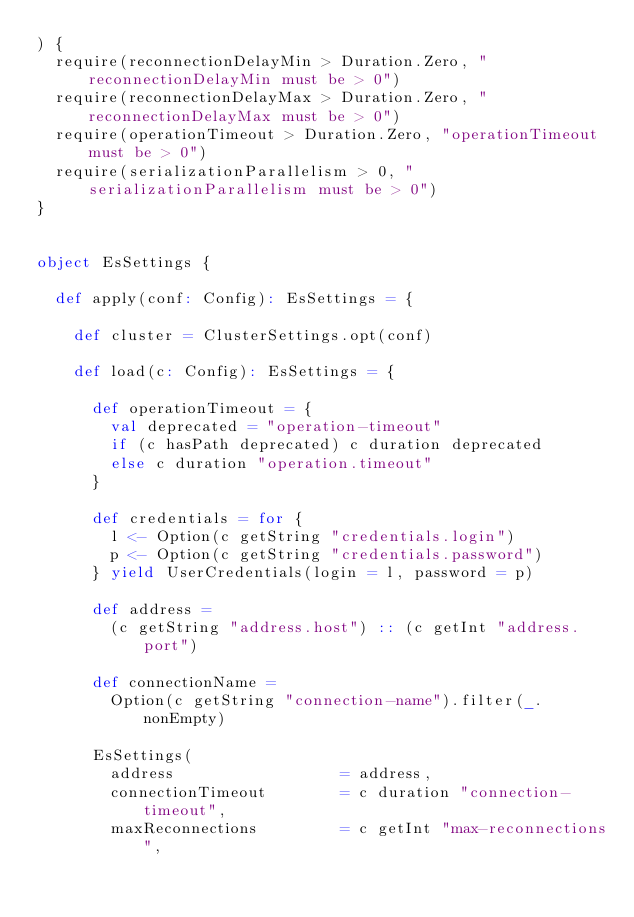<code> <loc_0><loc_0><loc_500><loc_500><_Scala_>) {
  require(reconnectionDelayMin > Duration.Zero, "reconnectionDelayMin must be > 0")
  require(reconnectionDelayMax > Duration.Zero, "reconnectionDelayMax must be > 0")
  require(operationTimeout > Duration.Zero, "operationTimeout must be > 0")
  require(serializationParallelism > 0, "serializationParallelism must be > 0")
}


object EsSettings {

  def apply(conf: Config): EsSettings = {

    def cluster = ClusterSettings.opt(conf)

    def load(c: Config): EsSettings = {

      def operationTimeout = {
        val deprecated = "operation-timeout"
        if (c hasPath deprecated) c duration deprecated
        else c duration "operation.timeout"
      }

      def credentials = for {
        l <- Option(c getString "credentials.login")
        p <- Option(c getString "credentials.password")
      } yield UserCredentials(login = l, password = p)

      def address =
        (c getString "address.host") :: (c getInt "address.port")

      def connectionName =
        Option(c getString "connection-name").filter(_.nonEmpty)

      EsSettings(
        address                  = address,
        connectionTimeout        = c duration "connection-timeout",
        maxReconnections         = c getInt "max-reconnections",</code> 